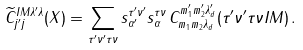<formula> <loc_0><loc_0><loc_500><loc_500>\widetilde { C } ^ { I M \lambda ^ { \prime } \lambda } _ { j ^ { \prime } j } ( X ) = \sum _ { \tau ^ { \prime } \nu ^ { \prime } \tau \nu } s _ { \alpha ^ { \prime } } ^ { \tau ^ { \prime } \nu ^ { \prime } } s _ { \alpha } ^ { \tau \nu } \, C ^ { m _ { 1 } ^ { \prime } m _ { 2 } ^ { \prime } \lambda _ { d } ^ { \prime } } _ { m _ { 1 } m _ { 2 } \lambda _ { d } } ( \tau ^ { \prime } \nu ^ { \prime } \tau \nu I M ) \, .</formula> 